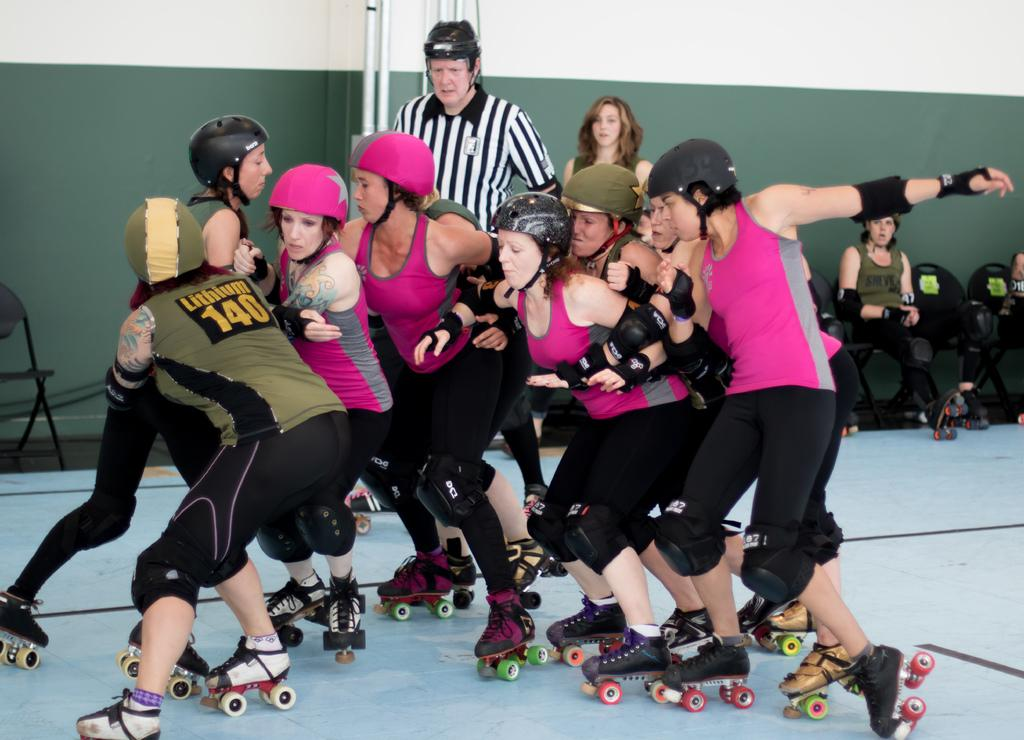<image>
Provide a brief description of the given image. A small tussle breaks out during a roller derby event, involving a player who has the number 140 and the word Lithium on her uniform. 